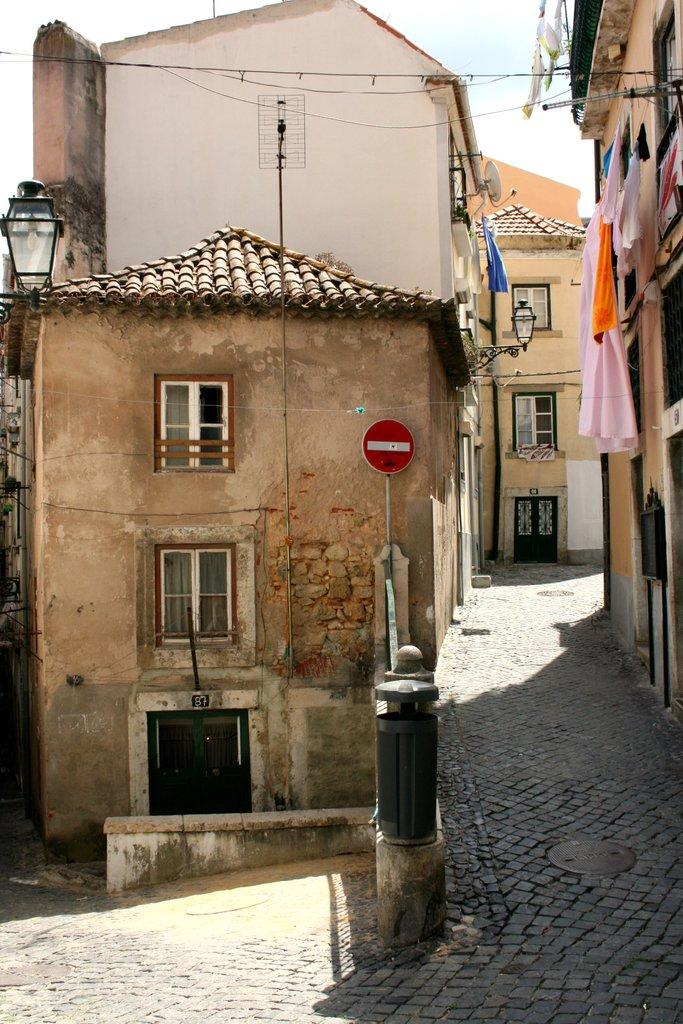What type of structures can be seen in the image? There are buildings in the image. What else is visible in the image besides the buildings? There are lights, clothes, windows, and a red color sign board in the image. What type of teeth can be seen on the maid in the image? There is no maid present in the image, and therefore no teeth can be observed. 